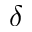Convert formula to latex. <formula><loc_0><loc_0><loc_500><loc_500>\delta</formula> 